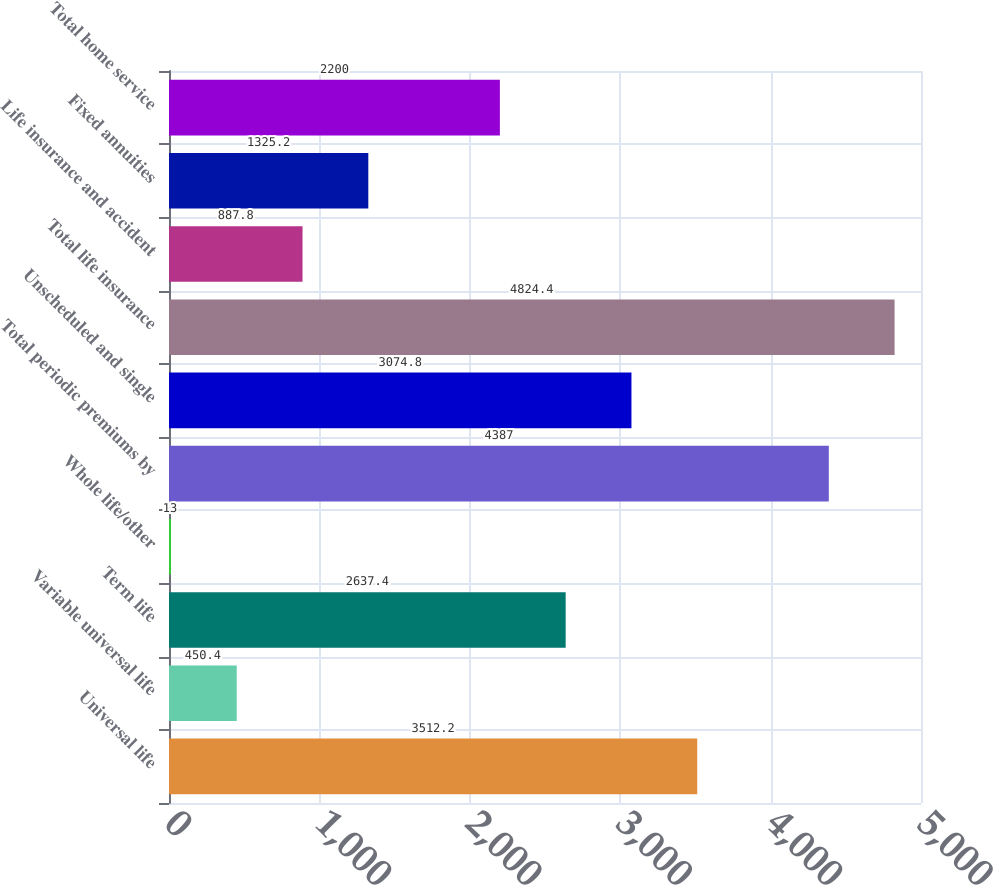Convert chart. <chart><loc_0><loc_0><loc_500><loc_500><bar_chart><fcel>Universal life<fcel>Variable universal life<fcel>Term life<fcel>Whole life/other<fcel>Total periodic premiums by<fcel>Unscheduled and single<fcel>Total life insurance<fcel>Life insurance and accident<fcel>Fixed annuities<fcel>Total home service<nl><fcel>3512.2<fcel>450.4<fcel>2637.4<fcel>13<fcel>4387<fcel>3074.8<fcel>4824.4<fcel>887.8<fcel>1325.2<fcel>2200<nl></chart> 